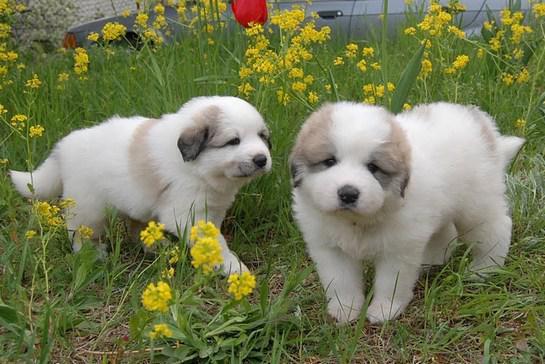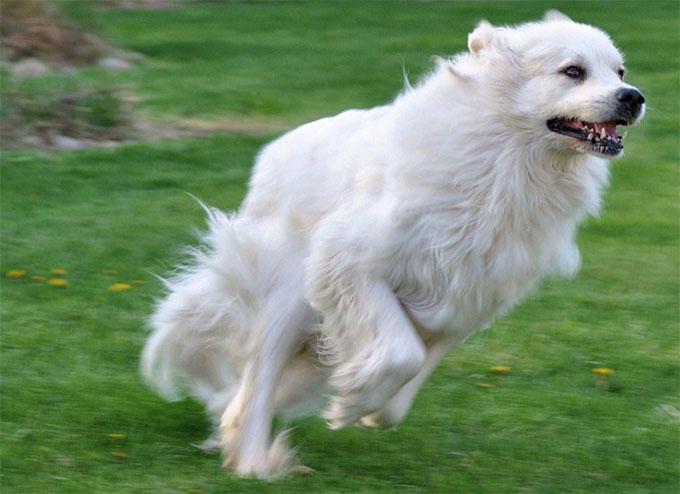The first image is the image on the left, the second image is the image on the right. For the images shown, is this caption "An image features exactly two nearly identical dogs." true? Answer yes or no. Yes. The first image is the image on the left, the second image is the image on the right. Evaluate the accuracy of this statement regarding the images: "There is a dog standing next to a fence.". Is it true? Answer yes or no. No. 